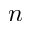Convert formula to latex. <formula><loc_0><loc_0><loc_500><loc_500>n</formula> 